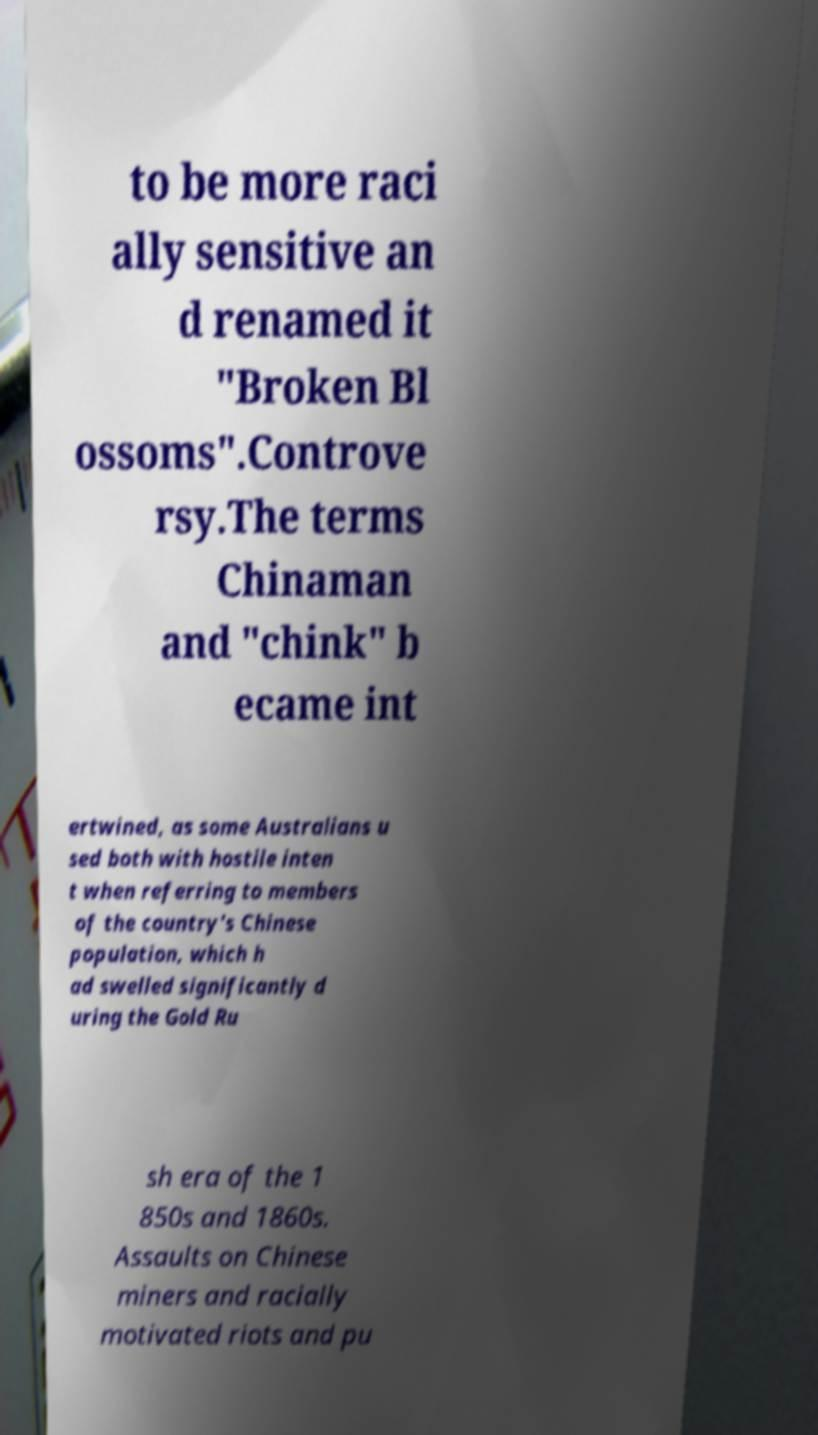Please identify and transcribe the text found in this image. to be more raci ally sensitive an d renamed it "Broken Bl ossoms".Controve rsy.The terms Chinaman and "chink" b ecame int ertwined, as some Australians u sed both with hostile inten t when referring to members of the country's Chinese population, which h ad swelled significantly d uring the Gold Ru sh era of the 1 850s and 1860s. Assaults on Chinese miners and racially motivated riots and pu 